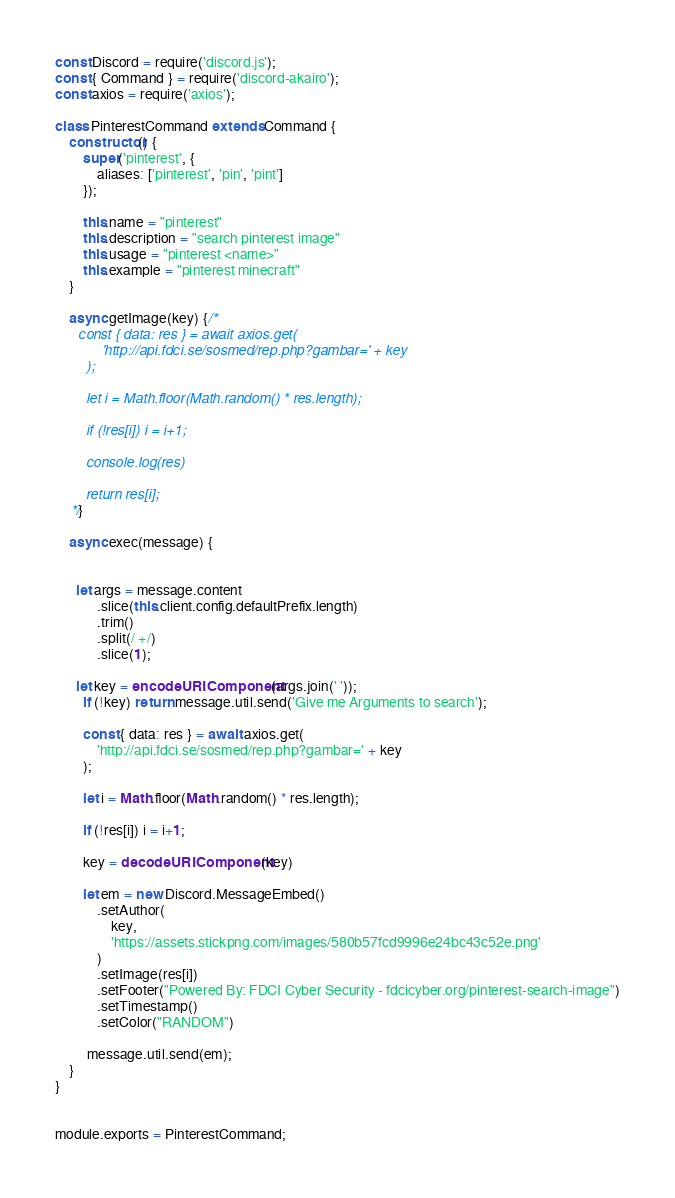Convert code to text. <code><loc_0><loc_0><loc_500><loc_500><_JavaScript_>const Discord = require('discord.js');
const { Command } = require('discord-akairo');
const axios = require('axios');

class PinterestCommand extends Command {
	constructor() {
		super('pinterest', {
			aliases: ['pinterest', 'pin', 'pint']
		});
		
		this.name = "pinterest"
		this.description = "search pinterest image"
		this.usage = "pinterest <name>"
		this.example = "pinterest minecraft"
	}
	
	async getImage(key) {/*
	  const { data: res } = await axios.get(
			'http://api.fdci.se/sosmed/rep.php?gambar=' + key
		);
		
		let i = Math.floor(Math.random() * res.length);

		if (!res[i]) i = i+1;
		
		console.log(res)
		
		return res[i];
	*/}
	
	async exec(message) {
		
	  
	  let args = message.content
			.slice(this.client.config.defaultPrefix.length)
			.trim()
			.split(/ +/)
			.slice(1);
	  
	  let key = encodeURIComponent(args.join(' '));
		if (!key) return message.util.send('Give me Arguments to search');
		
		const { data: res } = await axios.get(
			'http://api.fdci.se/sosmed/rep.php?gambar=' + key
		);
		
		let i = Math.floor(Math.random() * res.length);

		if (!res[i]) i = i+1;
		
		key = decodeURIComponent(key)

		let em = new Discord.MessageEmbed()
			.setAuthor(
				key,
				'https://assets.stickpng.com/images/580b57fcd9996e24bc43c52e.png'
			)
			.setImage(res[i])
			.setFooter("Powered By: FDCI Cyber Security - fdcicyber.org/pinterest-search-image")
			.setTimestamp()
			.setColor("RANDOM")

		 message.util.send(em);
	}
}
	

module.exports = PinterestCommand;
</code> 